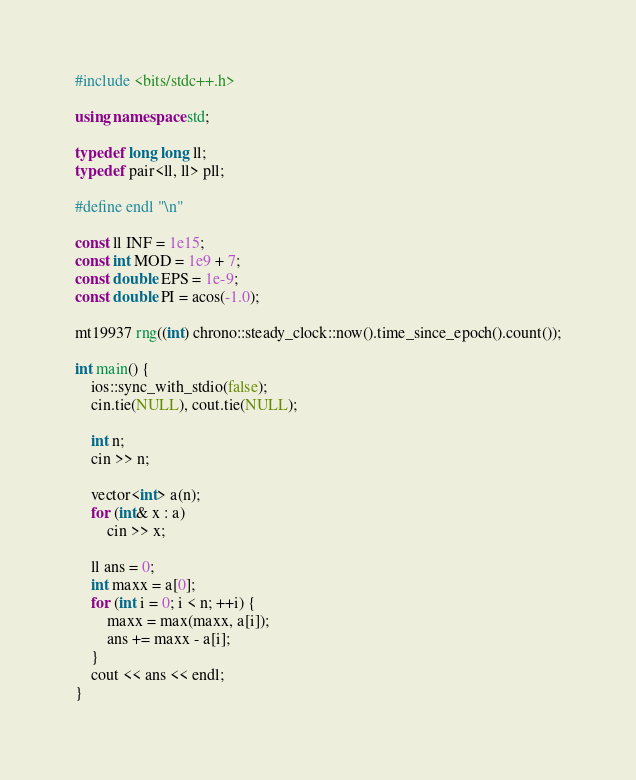Convert code to text. <code><loc_0><loc_0><loc_500><loc_500><_C++_>#include <bits/stdc++.h>
 
using namespace std;
 
typedef long long ll;
typedef pair<ll, ll> pll;
 
#define endl "\n"
 
const ll INF = 1e15;
const int MOD = 1e9 + 7;
const double EPS = 1e-9;
const double PI = acos(-1.0);
 
mt19937 rng((int) chrono::steady_clock::now().time_since_epoch().count());

int main() {
    ios::sync_with_stdio(false);
    cin.tie(NULL), cout.tie(NULL);

    int n;
    cin >> n;

    vector<int> a(n);
    for (int& x : a)
        cin >> x;

    ll ans = 0;
    int maxx = a[0];
    for (int i = 0; i < n; ++i) {
        maxx = max(maxx, a[i]);
        ans += maxx - a[i];
    }
    cout << ans << endl;
}
</code> 